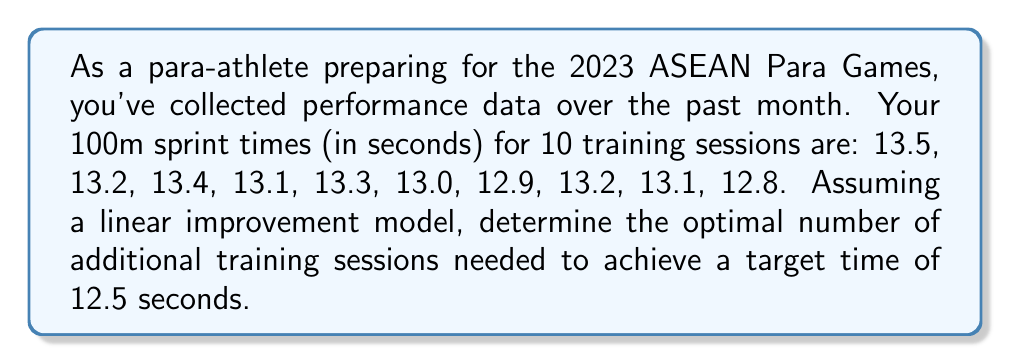Solve this math problem. Let's approach this step-by-step using an inverse problem framework:

1) First, we need to establish our linear model. Let $y$ be the sprint time and $x$ be the training session number. Our model is:

   $y = mx + b$

   where $m$ is the slope (improvement rate) and $b$ is the y-intercept (initial time).

2) To find $m$ and $b$, we can use the least squares method. Let's set up the equations:

   $$\begin{aligned}
   \sum y &= mn + b\sum x \\
   \sum xy &= m\sum x^2 + b\sum x
   \end{aligned}$$

3) Calculate the required sums:
   $n = 10$
   $\sum x = 55$
   $\sum x^2 = 385$
   $\sum y = 131.5$
   $\sum xy = 715.5$

4) Substitute into our equations:

   $$\begin{aligned}
   131.5 &= 10m + 55b \\
   715.5 &= 385m + 55b
   \end{aligned}$$

5) Solve this system of equations:
   $m \approx -0.0618$ and $b \approx 13.6145$

6) Our model is thus: $y = -0.0618x + 13.6145$

7) To find when we'll reach 12.5 seconds, solve:
   $12.5 = -0.0618x + 13.6145$
   $x \approx 18.03$

8) Since we've already had 10 sessions, we need approximately 8 more sessions.
Answer: 8 additional training sessions 